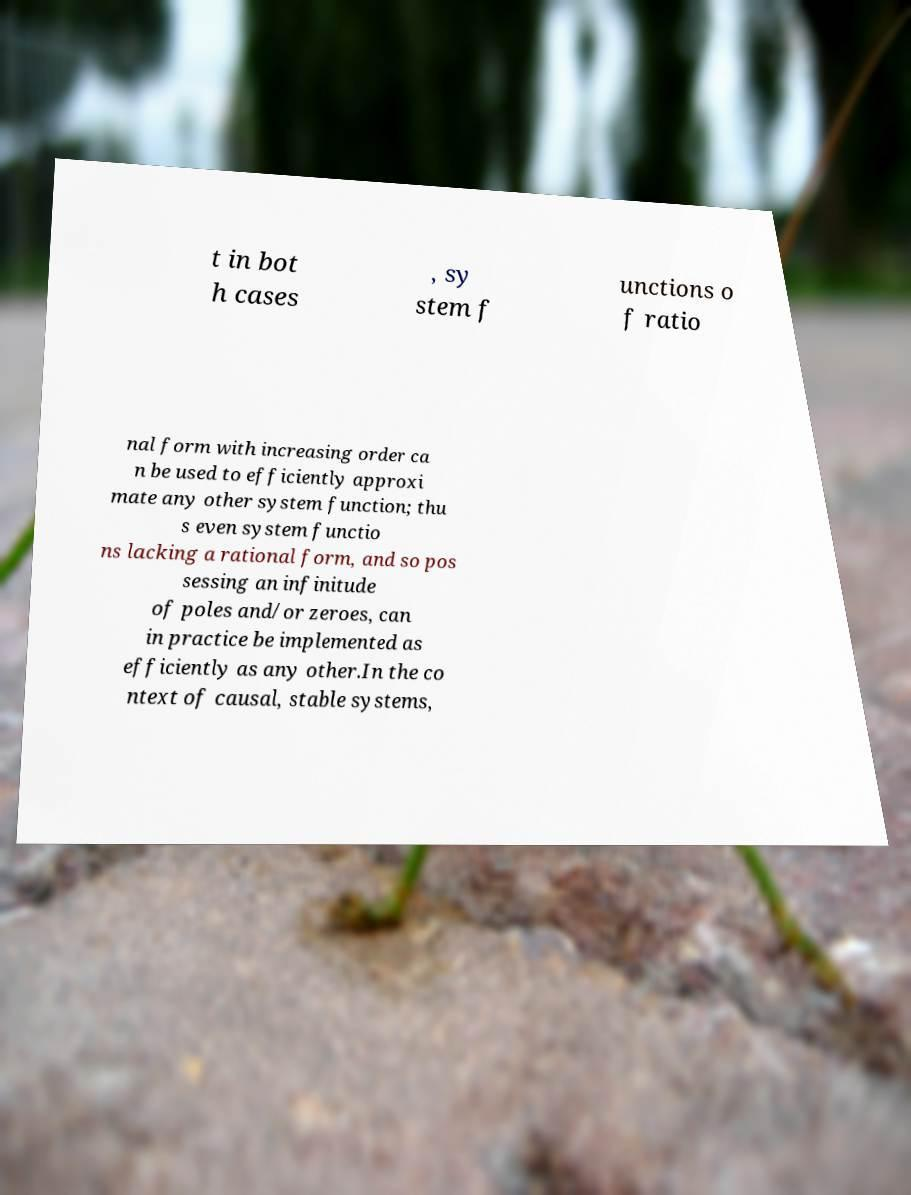Can you accurately transcribe the text from the provided image for me? t in bot h cases , sy stem f unctions o f ratio nal form with increasing order ca n be used to efficiently approxi mate any other system function; thu s even system functio ns lacking a rational form, and so pos sessing an infinitude of poles and/or zeroes, can in practice be implemented as efficiently as any other.In the co ntext of causal, stable systems, 